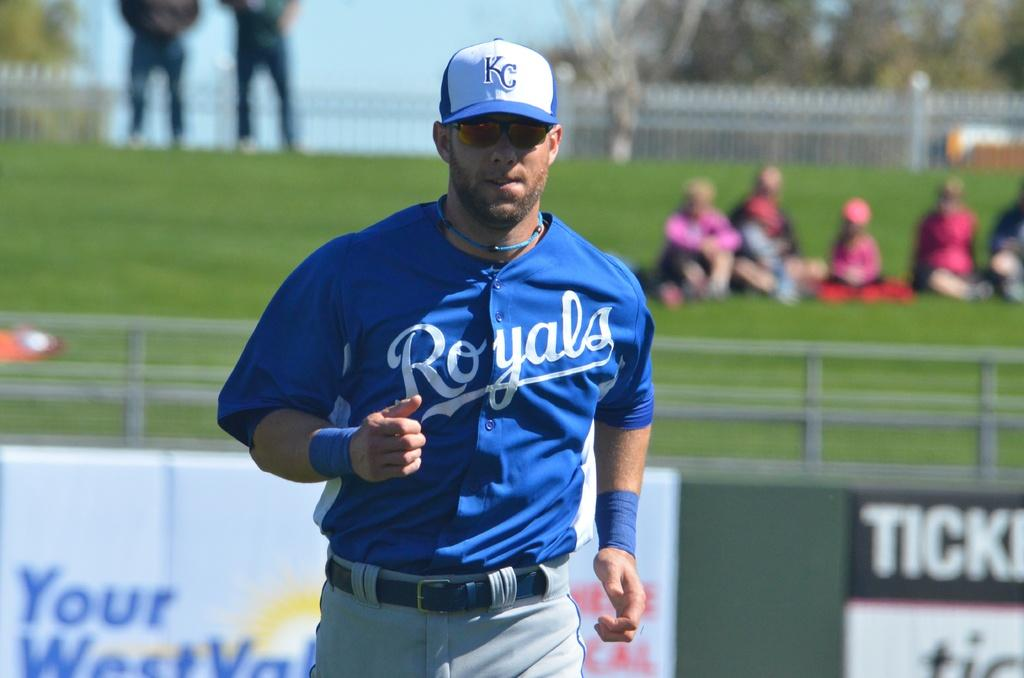<image>
Relay a brief, clear account of the picture shown. A Royals baseball player is running on the baseball field. 